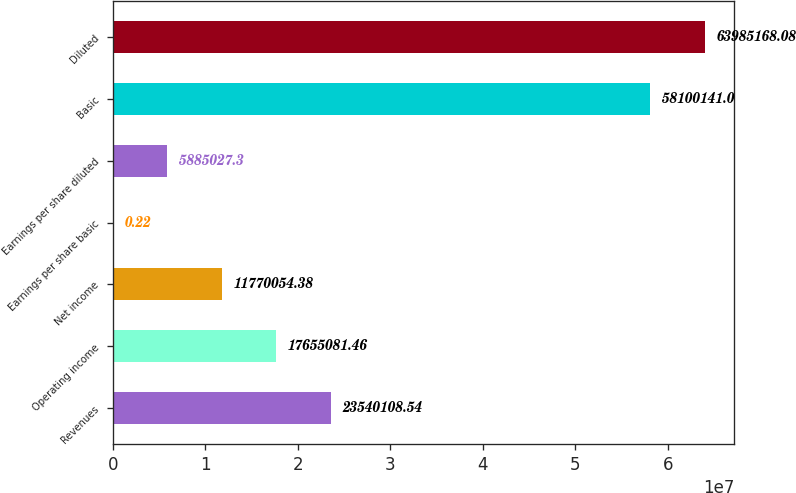Convert chart. <chart><loc_0><loc_0><loc_500><loc_500><bar_chart><fcel>Revenues<fcel>Operating income<fcel>Net income<fcel>Earnings per share basic<fcel>Earnings per share diluted<fcel>Basic<fcel>Diluted<nl><fcel>2.35401e+07<fcel>1.76551e+07<fcel>1.17701e+07<fcel>0.22<fcel>5.88503e+06<fcel>5.81001e+07<fcel>6.39852e+07<nl></chart> 